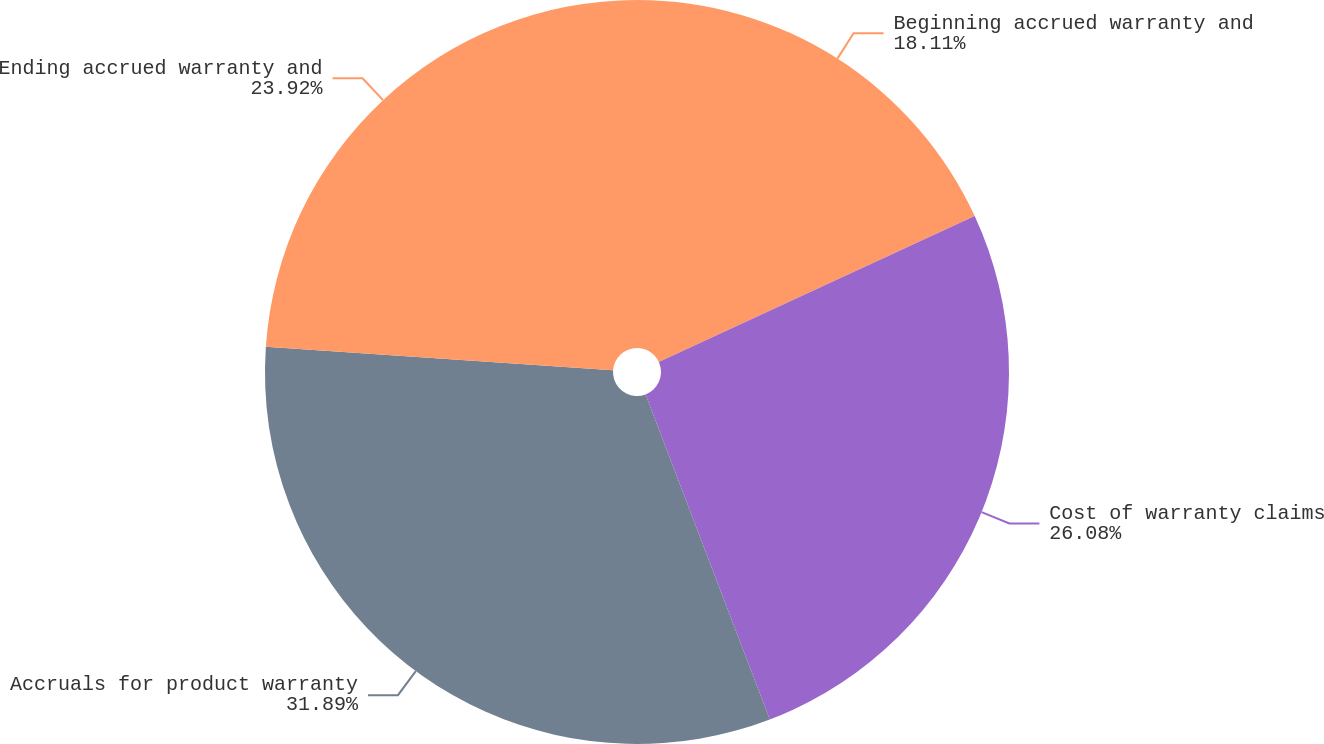Convert chart to OTSL. <chart><loc_0><loc_0><loc_500><loc_500><pie_chart><fcel>Beginning accrued warranty and<fcel>Cost of warranty claims<fcel>Accruals for product warranty<fcel>Ending accrued warranty and<nl><fcel>18.11%<fcel>26.08%<fcel>31.89%<fcel>23.92%<nl></chart> 